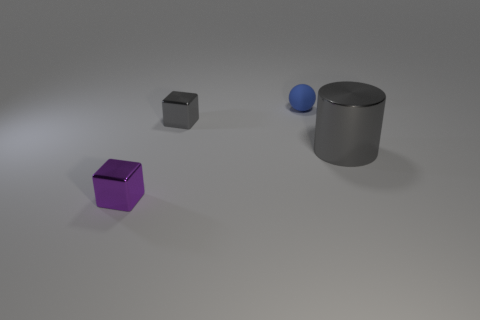Is the size of the gray block the same as the blue ball?
Offer a very short reply. Yes. There is a tiny gray metal thing; what number of purple shiny objects are left of it?
Your answer should be compact. 1. Are there the same number of shiny cubes that are behind the tiny purple shiny thing and shiny cylinders that are on the right side of the small blue matte sphere?
Offer a very short reply. Yes. Does the metal thing that is behind the large gray cylinder have the same shape as the small blue object?
Make the answer very short. No. Are there any other things that have the same material as the tiny sphere?
Make the answer very short. No. There is a blue rubber ball; is its size the same as the gray metal object on the left side of the rubber ball?
Give a very brief answer. Yes. How many other objects are there of the same color as the tiny matte sphere?
Your answer should be very brief. 0. Are there any shiny things on the right side of the purple metal block?
Your response must be concise. Yes. How many objects are large cyan shiny things or small metal cubes that are in front of the small gray thing?
Your answer should be compact. 1. Are there any purple shiny blocks behind the cube behind the purple block?
Your response must be concise. No. 